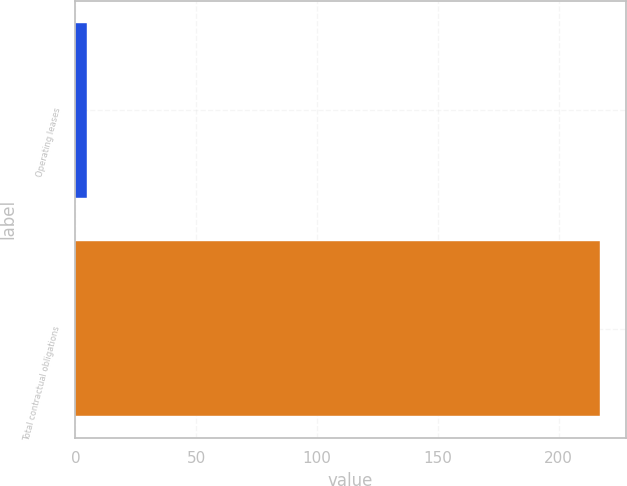Convert chart to OTSL. <chart><loc_0><loc_0><loc_500><loc_500><bar_chart><fcel>Operating leases<fcel>Total contractual obligations<nl><fcel>4.8<fcel>217<nl></chart> 